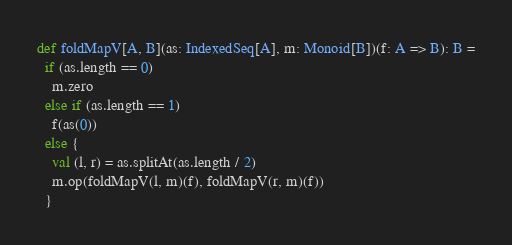<code> <loc_0><loc_0><loc_500><loc_500><_Scala_>def foldMapV[A, B](as: IndexedSeq[A], m: Monoid[B])(f: A => B): B =
  if (as.length == 0)
    m.zero
  else if (as.length == 1)
    f(as(0))
  else {
    val (l, r) = as.splitAt(as.length / 2)
    m.op(foldMapV(l, m)(f), foldMapV(r, m)(f))
  }</code> 